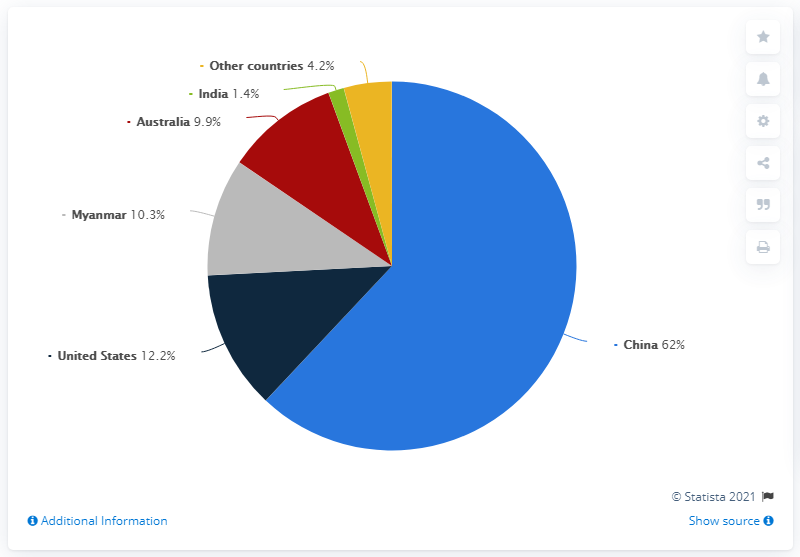Point out several critical features in this image. In the three smallest segments, the median is 4.2. The China segment, minus the segment that provides the largest difference, is India. In 2019, China was the world's leading producer of rare earth elements. 